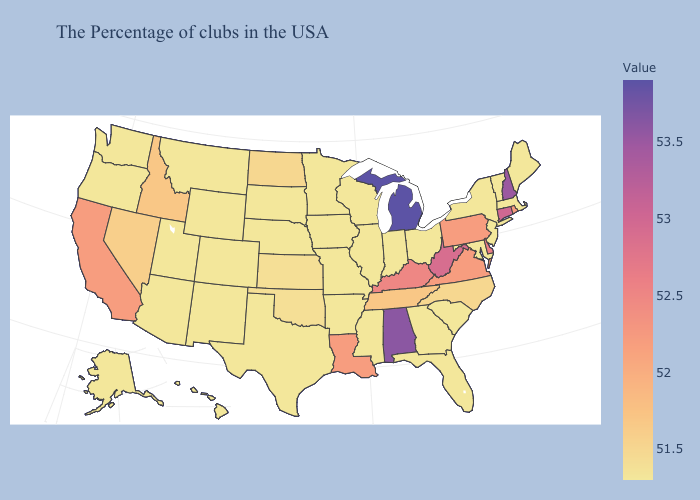Does Nebraska have a lower value than California?
Answer briefly. Yes. Does New Hampshire have the lowest value in the USA?
Be succinct. No. Does the map have missing data?
Quick response, please. No. Does the map have missing data?
Quick response, please. No. Among the states that border Louisiana , which have the highest value?
Write a very short answer. Mississippi, Arkansas, Texas. 